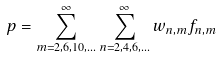Convert formula to latex. <formula><loc_0><loc_0><loc_500><loc_500>p = \sum _ { m = 2 , 6 , 1 0 , \dots } ^ { \infty } \sum _ { n = 2 , 4 , 6 , \dots } ^ { \infty } w _ { n , m } f _ { n , m }</formula> 